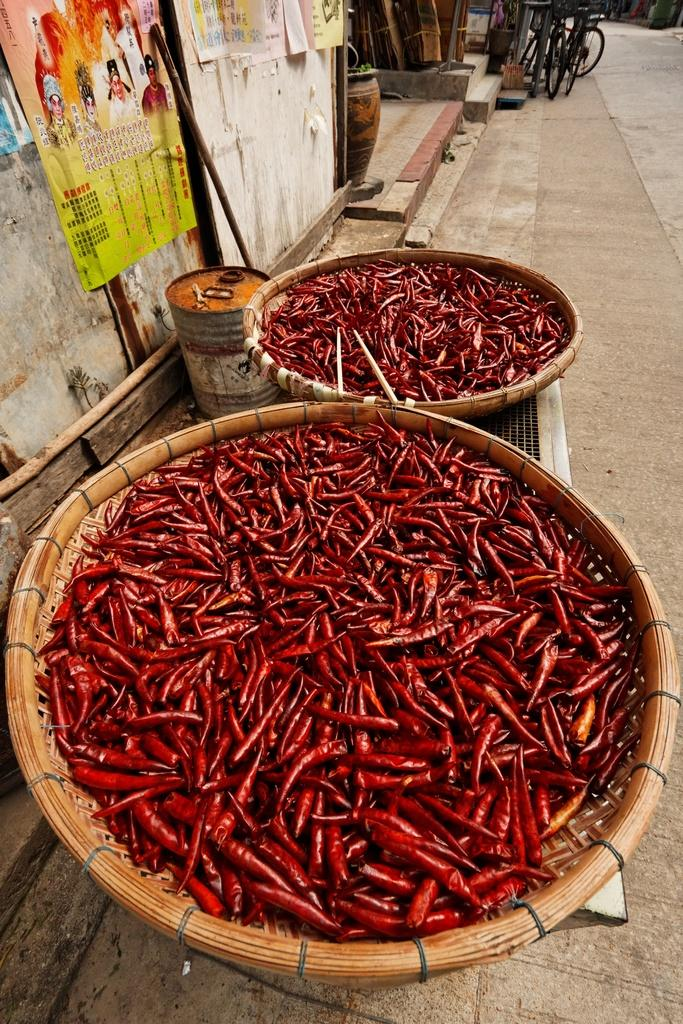What type of food item is present in the image? There are red chillies in the image. How are the red chillies arranged or stored? The red chillies are placed in baskets. What can be seen on the wall on the left side of the image? There are posters on the wall on the left side of the image. What can be seen in the background of the image? There are bicycles in the background of the image. What type of jar is used to store the red chillies in the image? There is no jar present in the image; the red chillies are placed in baskets. 